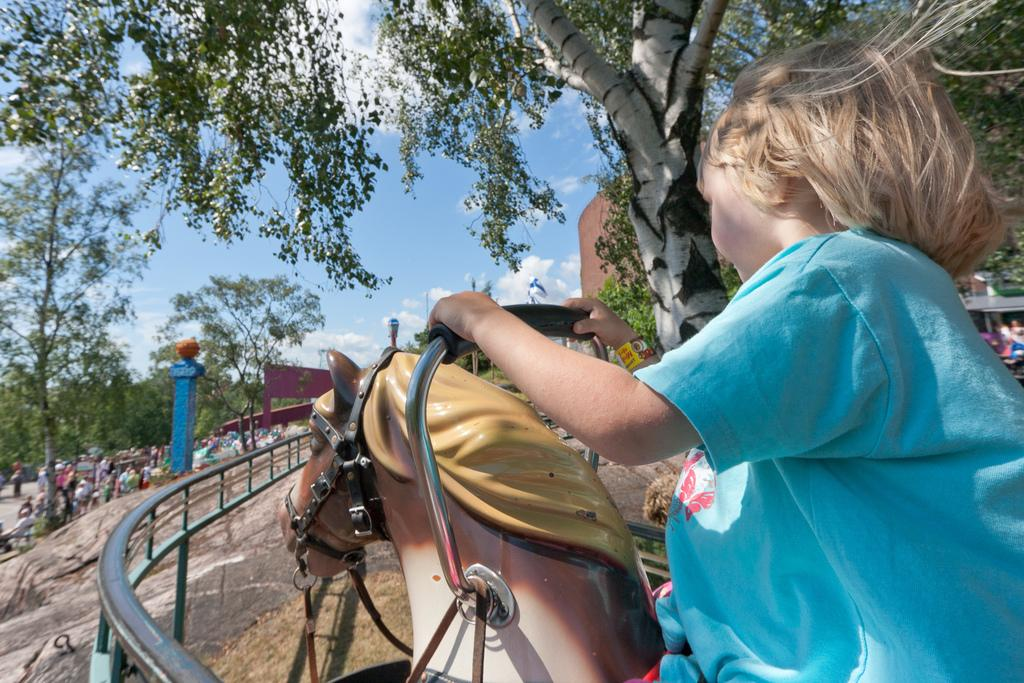What is the main subject of the image? There is a child in the image. What is the child doing in the image? The child is sitting on a toy horse. What can be seen in the background of the image? There is a tree, railing, a building, and the sky visible in the image. Are there any other people in the image besides the child? Yes, there is a crowd in the left corner of the image. What grade did the child receive for their opinion paper in the image? There is no mention of an opinion paper or a grade in the image. The image only shows a child sitting on a toy horse with a background of a tree, railing, building, and sky, along with a crowd in the left corner. 